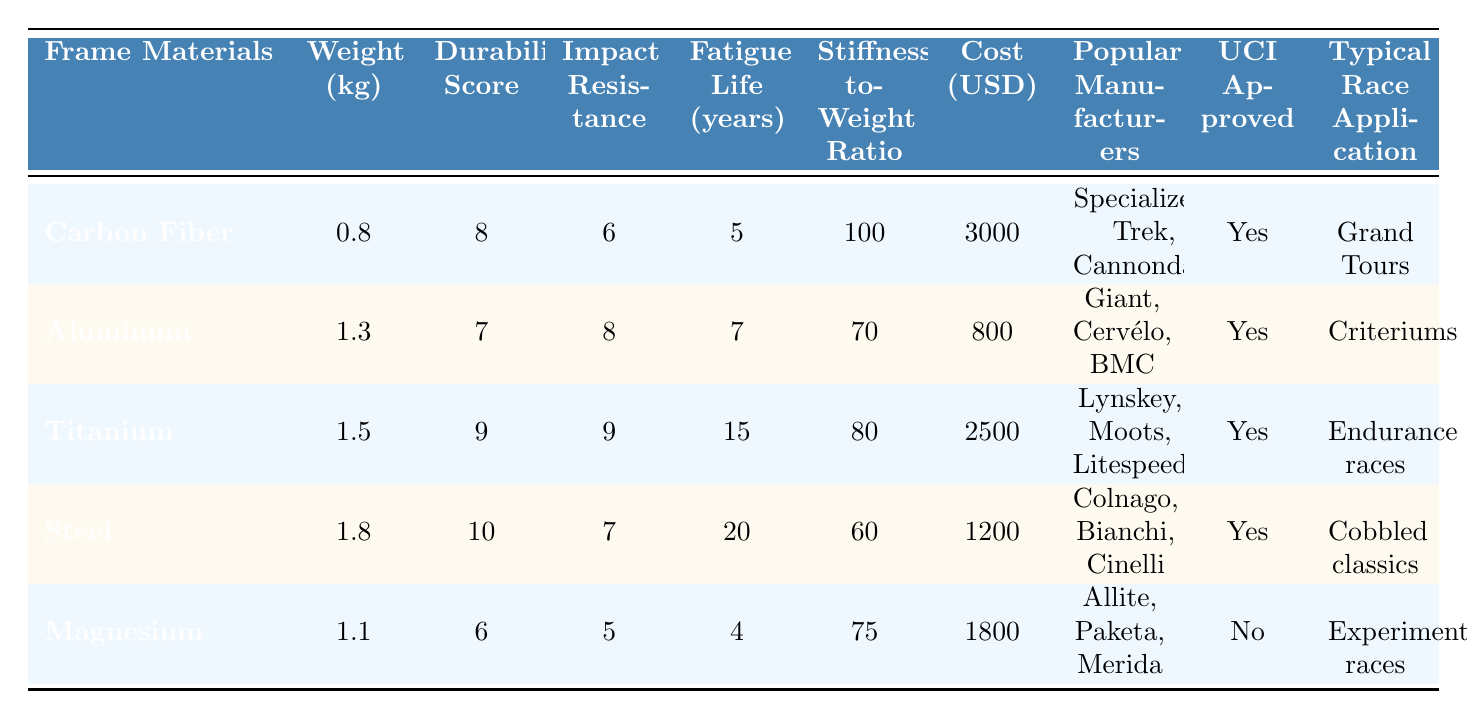What is the weight of the Carbon Fiber frame? The table lists the weight of the Carbon Fiber frame as 0.8 kg.
Answer: 0.8 kg Which frame material has the highest durability score? In the table, Steel has the highest durability score of 10.
Answer: Steel What is the average cost of the frame materials listed? The total cost is (3000 + 800 + 2500 + 1200 + 1800) = 10300, and there are 5 frame materials, so the average cost is 10300 / 5 = 2060.
Answer: 2060 USD Which frame materials are UCI approved? By checking the UCI Approved column, all materials except Magnesium are list as "Yes," which includes Carbon Fiber, Aluminum, Titanium, and Steel.
Answer: Carbon Fiber, Aluminum, Titanium, Steel Is the Titanium frame suitable for Grand Tours? The Typical Race Application for Titanium is "Endurance races," which indicates it is not specifically designed for Grand Tours as indicated by the table.
Answer: No What is the difference in weight between the lightest and heaviest frame materials? The weight of the lightest frame material, Carbon Fiber, is 0.8 kg, and the heaviest is Steel at 1.8 kg. The difference is 1.8 - 0.8 = 1.0 kg.
Answer: 1.0 kg Which frame material has the longest fatigue life? By reviewing the Fatigue Life column, Steel has the longest fatigue life of 20 years, compared to the others.
Answer: Steel What is the stiffness-to-weight ratio of the Aluminum frame? The table shows that the stiffness-to-weight ratio for the Aluminum frame is 70.
Answer: 70 How many frame materials have a cost of less than 1000 USD? The cost of materials shows that only Aluminum at 800 USD fits this criterion, so there is 1 material.
Answer: 1 Which frame material has both the lowest impact resistance and durability score? The Magnesium frame has the lowest impact resistance (5) and the lowest durability score (6) among all the materials in the table.
Answer: Magnesium If I want the lightest and most durable option, which frame should I choose? Carbon Fiber has a lower weight (0.8 kg) compared to Titanium (1.5 kg) while having a decent durability score of 8, but Titanium has a higher durability score of 9. Combining weight and durability, Carbon Fiber is the lighter option, making it suitable if weight is prioritized higher than durability which might suit Grand Tours.
Answer: Carbon Fiber 